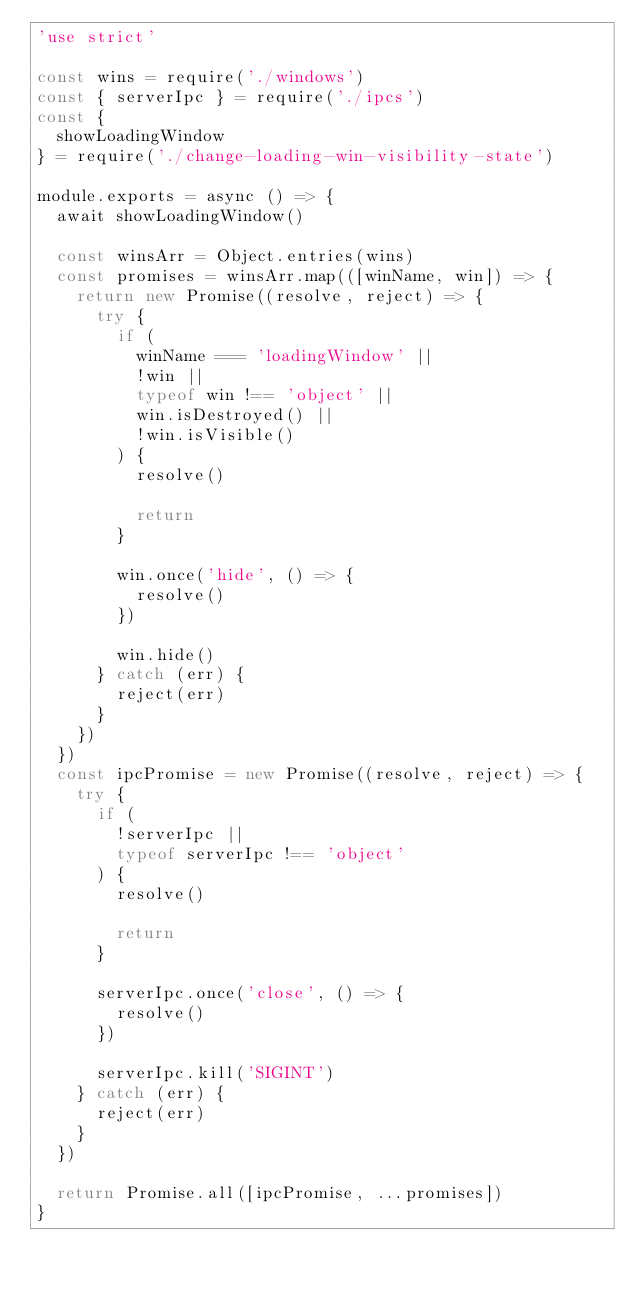Convert code to text. <code><loc_0><loc_0><loc_500><loc_500><_JavaScript_>'use strict'

const wins = require('./windows')
const { serverIpc } = require('./ipcs')
const {
  showLoadingWindow
} = require('./change-loading-win-visibility-state')

module.exports = async () => {
  await showLoadingWindow()

  const winsArr = Object.entries(wins)
  const promises = winsArr.map(([winName, win]) => {
    return new Promise((resolve, reject) => {
      try {
        if (
          winName === 'loadingWindow' ||
          !win ||
          typeof win !== 'object' ||
          win.isDestroyed() ||
          !win.isVisible()
        ) {
          resolve()

          return
        }

        win.once('hide', () => {
          resolve()
        })

        win.hide()
      } catch (err) {
        reject(err)
      }
    })
  })
  const ipcPromise = new Promise((resolve, reject) => {
    try {
      if (
        !serverIpc ||
        typeof serverIpc !== 'object'
      ) {
        resolve()

        return
      }

      serverIpc.once('close', () => {
        resolve()
      })

      serverIpc.kill('SIGINT')
    } catch (err) {
      reject(err)
    }
  })

  return Promise.all([ipcPromise, ...promises])
}
</code> 